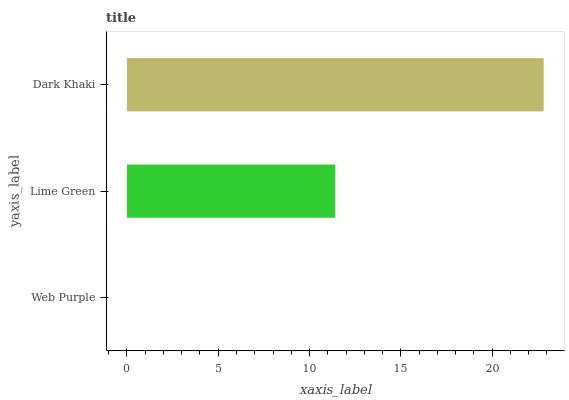Is Web Purple the minimum?
Answer yes or no. Yes. Is Dark Khaki the maximum?
Answer yes or no. Yes. Is Lime Green the minimum?
Answer yes or no. No. Is Lime Green the maximum?
Answer yes or no. No. Is Lime Green greater than Web Purple?
Answer yes or no. Yes. Is Web Purple less than Lime Green?
Answer yes or no. Yes. Is Web Purple greater than Lime Green?
Answer yes or no. No. Is Lime Green less than Web Purple?
Answer yes or no. No. Is Lime Green the high median?
Answer yes or no. Yes. Is Lime Green the low median?
Answer yes or no. Yes. Is Web Purple the high median?
Answer yes or no. No. Is Web Purple the low median?
Answer yes or no. No. 